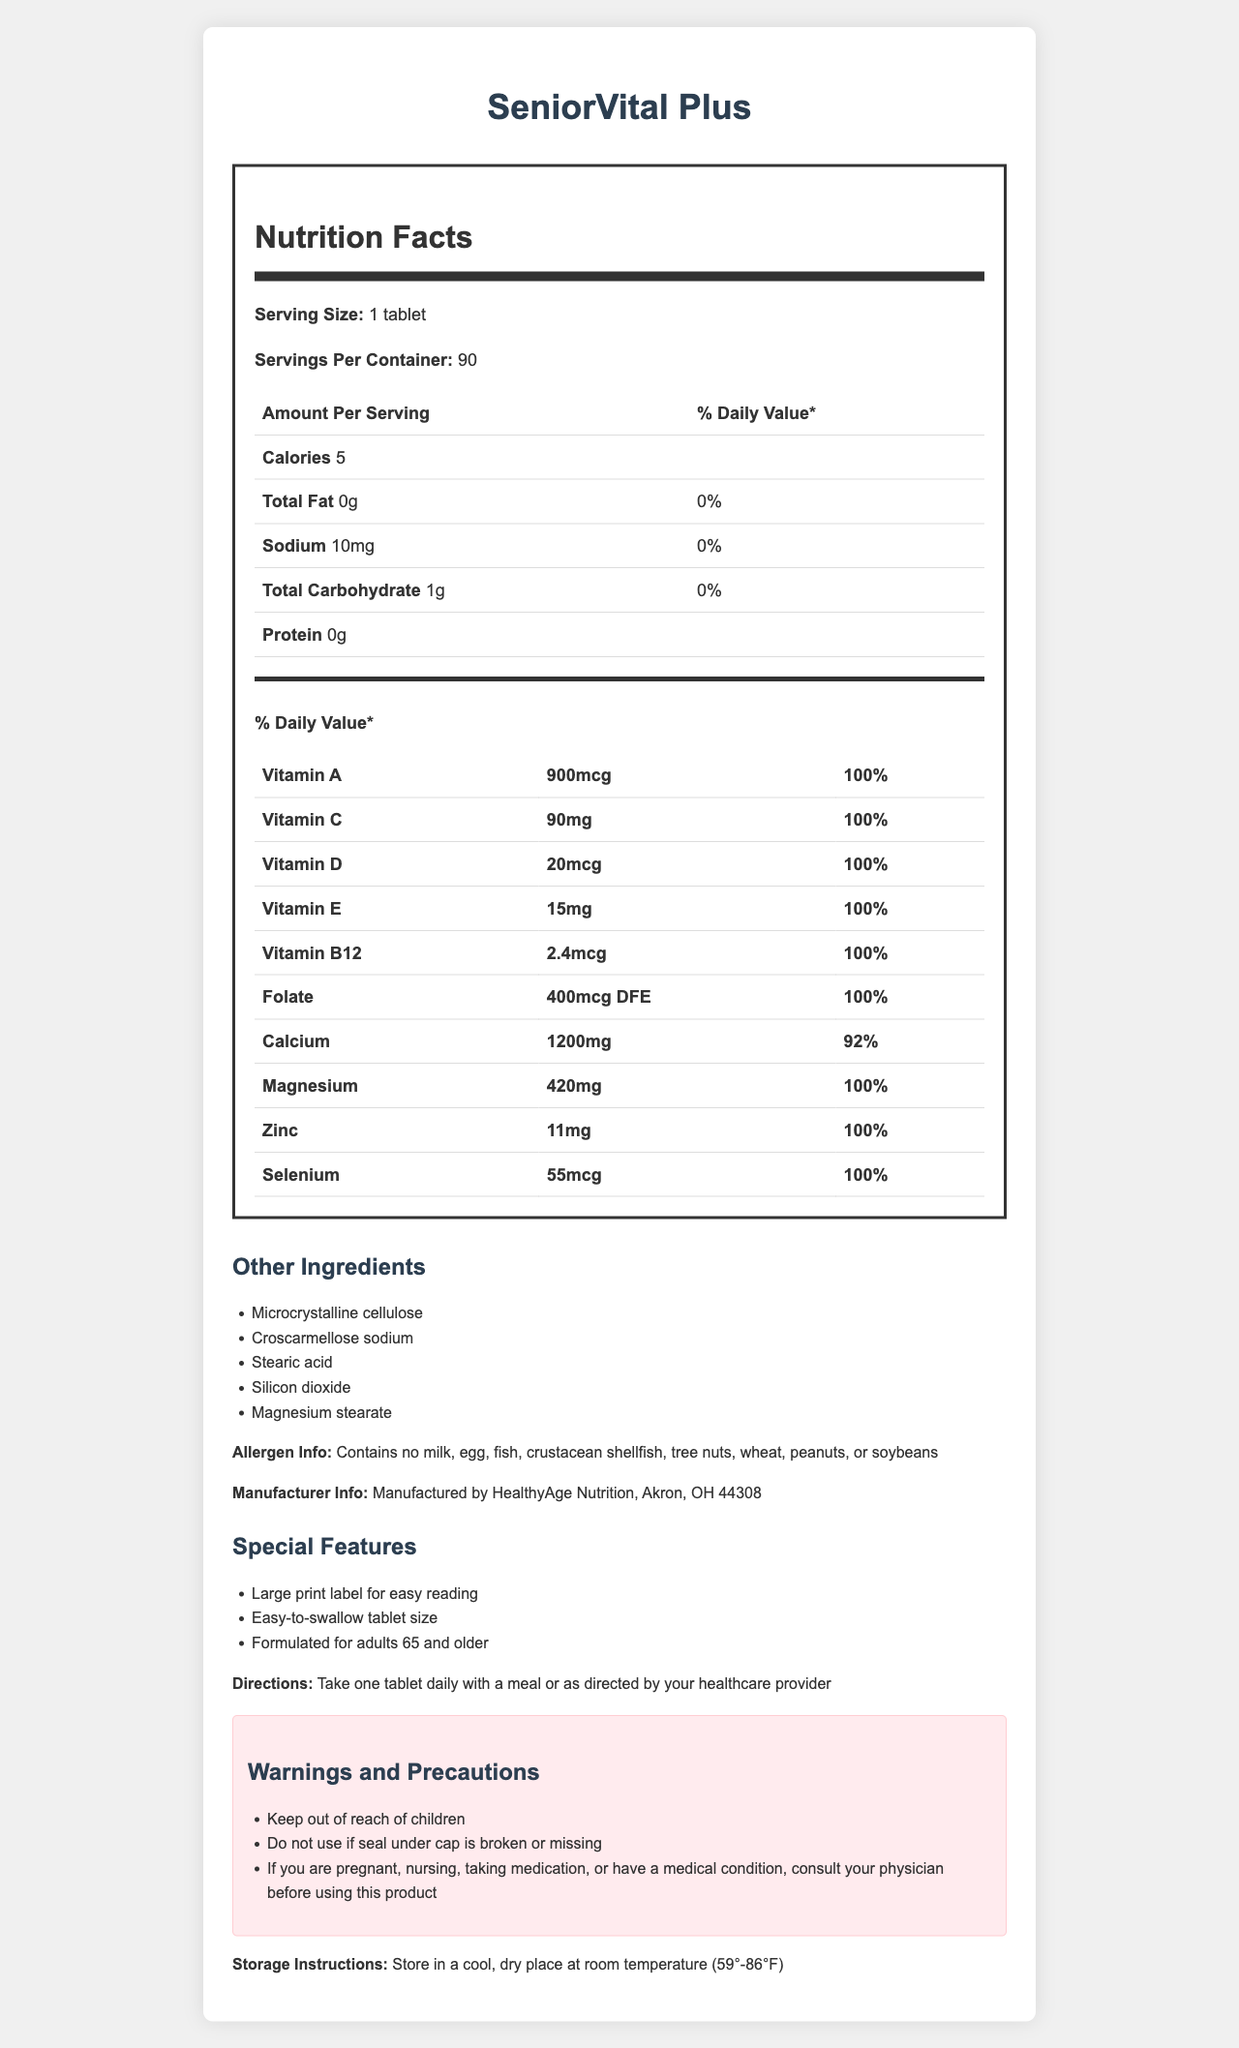what is the product name? The product name "SeniorVital Plus" is prominently displayed at the top of the document.
Answer: SeniorVital Plus what is the serving size? The serving size is clearly stated as "1 tablet" in the nutrition facts section.
Answer: 1 tablet how many servings are in one container? It says "Servings Per Container: 90" in the nutrition facts section.
Answer: 90 how many calories are in one tablet? Under the nutrition facts, "Calories: 5" is listed for one serving size (1 tablet).
Answer: 5 calories is there any sodium in this supplement? The nutrition facts show "Sodium: 10mg".
Answer: Yes what is the percentage daily value of calcium? The percentage daily value for calcium is listed as "92%" in the daily value table.
Answer: 92% what vitamins are included in the supplement? These vitamins are listed in the "vitamins and minerals" section with their respective amounts and daily values.
Answer: Vitamin A, Vitamin C, Vitamin D, Vitamin E, Vitamin B12, Folate where is this supplement manufactured? The manufacturer info is "Manufactured by HealthyAge Nutrition, Akron, OH 44308".
Answer: HealthyAge Nutrition, Akron, OH 44308 what are the other ingredients in this supplement? These are listed under the “Other Ingredients” section of the document.
Answer: Microcrystalline cellulose, Croscarmellose sodium, Stearic acid, Silicon dioxide, Magnesium stearate how should the supplement be stored? The storage instructions specify to store in a temperature range of 59°-86°F.
Answer: Store in a cool, dry place at room temperature (59°-86°F) does the supplement contain any allergens such as milk or nuts? The supplement contains no milk, egg, fish, crustacean shellfish, tree nuts, wheat, peanuts, or soybeans as stated in the allergen info.
Answer: No what are the special features of this multivitamin? These features are listed under the "Special Features" section.
Answer: Large print label for easy reading, Easy-to-swallow tablet size, Formulated for adults 65 and older how often should one take this supplement? The directions state "Take one tablet daily with a meal or as directed by your healthcare provider".
Answer: Once daily with a meal what should one do if the seal under the cap is broken or missing? This is mentioned as one of the warnings and precautions.
Answer: Do not use the product what is the amount of Vitamin D per serving? A. 10mcg B. 20mcg C. 30mcg The amount of Vitamin D is listed as "20mcg" in the daily value table.
Answer: B. 20mcg what is the daily value percentage for magnesium? A. 90% B. 95% C. 100% D. 105% The daily value percentage for magnesium is clearly stated as "100%" in the daily value table.
Answer: C. 100% would it be suitable to store this supplement in a refrigerator? The storage instructions specify room temperature (59°-86°F) which implies it should not be stored in a refrigerator which is typically colder.
Answer: No how do you summarize the main features of SeniorVital Plus supplement? The summary cohesively captures the core details of the supplement including its purpose, formulation, intake instructions, and additional features.
Answer: SeniorVital Plus is a senior-friendly multivitamin supplement formulated for adults 65 and older. It includes essential vitamins and minerals with 100% daily value for most. The product features easy-to-read large print label and easy-to-swallow tablets. It's free from common allergens and should be taken once daily with a meal. who should be consulted if a person is taking medication and wants to use this product? One of the warnings mentions consulting a physician if you are pregnant, nursing, taking medication, or have a medical condition.
Answer: Consult your physician what are the possible side effects listed for SeniorVital Plus? The document does not provide details on potential side effects, so this information cannot be determined from the visual content.
Answer: Not enough information 